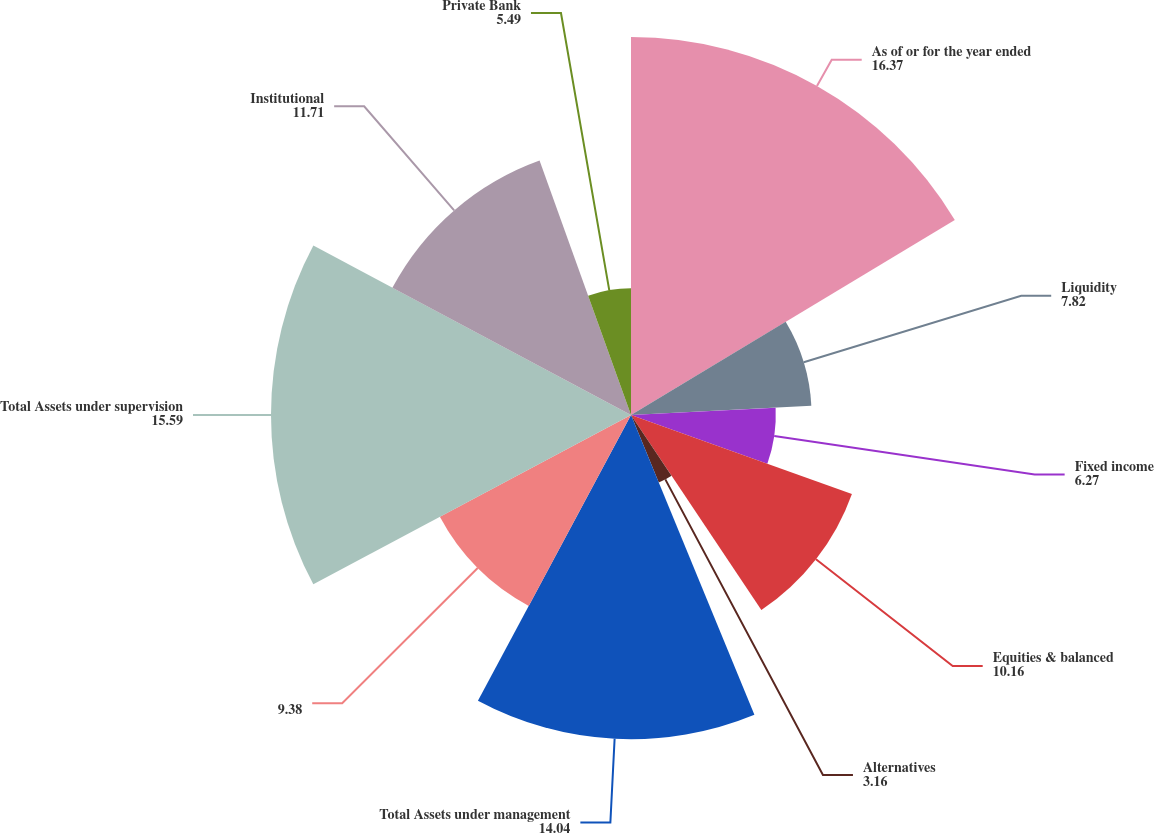Convert chart to OTSL. <chart><loc_0><loc_0><loc_500><loc_500><pie_chart><fcel>As of or for the year ended<fcel>Liquidity<fcel>Fixed income<fcel>Equities & balanced<fcel>Alternatives<fcel>Total Assets under management<fcel>Unnamed: 6<fcel>Total Assets under supervision<fcel>Institutional<fcel>Private Bank<nl><fcel>16.37%<fcel>7.82%<fcel>6.27%<fcel>10.16%<fcel>3.16%<fcel>14.04%<fcel>9.38%<fcel>15.59%<fcel>11.71%<fcel>5.49%<nl></chart> 